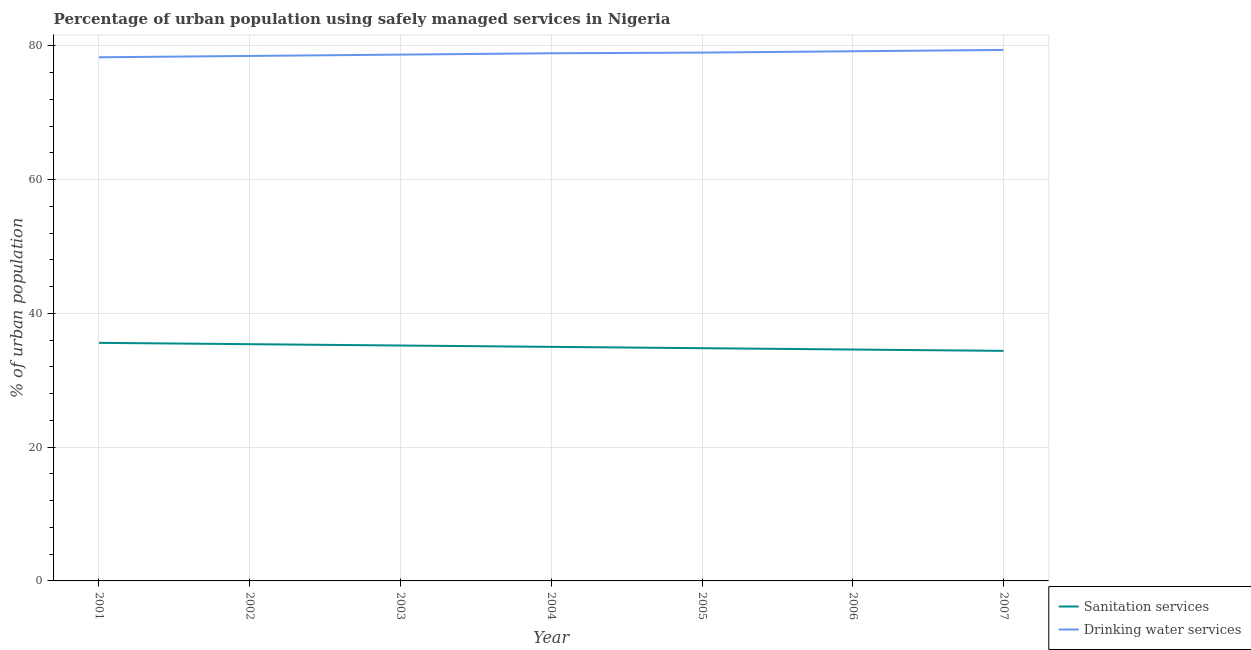Does the line corresponding to percentage of urban population who used drinking water services intersect with the line corresponding to percentage of urban population who used sanitation services?
Your response must be concise. No. What is the percentage of urban population who used sanitation services in 2007?
Ensure brevity in your answer.  34.4. Across all years, what is the maximum percentage of urban population who used drinking water services?
Provide a succinct answer. 79.4. Across all years, what is the minimum percentage of urban population who used drinking water services?
Ensure brevity in your answer.  78.3. In which year was the percentage of urban population who used drinking water services maximum?
Keep it short and to the point. 2007. In which year was the percentage of urban population who used drinking water services minimum?
Your response must be concise. 2001. What is the total percentage of urban population who used sanitation services in the graph?
Make the answer very short. 245. What is the difference between the percentage of urban population who used sanitation services in 2001 and that in 2003?
Give a very brief answer. 0.4. What is the difference between the percentage of urban population who used drinking water services in 2007 and the percentage of urban population who used sanitation services in 2006?
Provide a succinct answer. 44.8. What is the average percentage of urban population who used drinking water services per year?
Offer a terse response. 78.86. In the year 2001, what is the difference between the percentage of urban population who used drinking water services and percentage of urban population who used sanitation services?
Offer a very short reply. 42.7. In how many years, is the percentage of urban population who used drinking water services greater than 44 %?
Ensure brevity in your answer.  7. What is the ratio of the percentage of urban population who used sanitation services in 2002 to that in 2003?
Offer a very short reply. 1.01. What is the difference between the highest and the second highest percentage of urban population who used sanitation services?
Provide a short and direct response. 0.2. What is the difference between the highest and the lowest percentage of urban population who used sanitation services?
Ensure brevity in your answer.  1.2. Is the sum of the percentage of urban population who used drinking water services in 2001 and 2003 greater than the maximum percentage of urban population who used sanitation services across all years?
Your response must be concise. Yes. Does the percentage of urban population who used drinking water services monotonically increase over the years?
Give a very brief answer. Yes. Is the percentage of urban population who used drinking water services strictly less than the percentage of urban population who used sanitation services over the years?
Offer a terse response. No. How many years are there in the graph?
Offer a very short reply. 7. What is the difference between two consecutive major ticks on the Y-axis?
Make the answer very short. 20. Does the graph contain grids?
Offer a very short reply. Yes. Where does the legend appear in the graph?
Ensure brevity in your answer.  Bottom right. How are the legend labels stacked?
Ensure brevity in your answer.  Vertical. What is the title of the graph?
Offer a terse response. Percentage of urban population using safely managed services in Nigeria. Does "Private funds" appear as one of the legend labels in the graph?
Your answer should be very brief. No. What is the label or title of the Y-axis?
Your answer should be compact. % of urban population. What is the % of urban population of Sanitation services in 2001?
Your answer should be very brief. 35.6. What is the % of urban population of Drinking water services in 2001?
Offer a very short reply. 78.3. What is the % of urban population in Sanitation services in 2002?
Your answer should be compact. 35.4. What is the % of urban population in Drinking water services in 2002?
Make the answer very short. 78.5. What is the % of urban population of Sanitation services in 2003?
Your answer should be very brief. 35.2. What is the % of urban population of Drinking water services in 2003?
Provide a succinct answer. 78.7. What is the % of urban population of Sanitation services in 2004?
Your response must be concise. 35. What is the % of urban population of Drinking water services in 2004?
Make the answer very short. 78.9. What is the % of urban population of Sanitation services in 2005?
Give a very brief answer. 34.8. What is the % of urban population of Drinking water services in 2005?
Provide a short and direct response. 79. What is the % of urban population of Sanitation services in 2006?
Offer a terse response. 34.6. What is the % of urban population in Drinking water services in 2006?
Keep it short and to the point. 79.2. What is the % of urban population of Sanitation services in 2007?
Give a very brief answer. 34.4. What is the % of urban population in Drinking water services in 2007?
Offer a very short reply. 79.4. Across all years, what is the maximum % of urban population of Sanitation services?
Provide a succinct answer. 35.6. Across all years, what is the maximum % of urban population in Drinking water services?
Your response must be concise. 79.4. Across all years, what is the minimum % of urban population in Sanitation services?
Offer a very short reply. 34.4. Across all years, what is the minimum % of urban population of Drinking water services?
Ensure brevity in your answer.  78.3. What is the total % of urban population of Sanitation services in the graph?
Provide a short and direct response. 245. What is the total % of urban population of Drinking water services in the graph?
Provide a succinct answer. 552. What is the difference between the % of urban population of Sanitation services in 2001 and that in 2003?
Ensure brevity in your answer.  0.4. What is the difference between the % of urban population in Drinking water services in 2001 and that in 2003?
Provide a succinct answer. -0.4. What is the difference between the % of urban population of Sanitation services in 2001 and that in 2004?
Make the answer very short. 0.6. What is the difference between the % of urban population in Sanitation services in 2001 and that in 2005?
Ensure brevity in your answer.  0.8. What is the difference between the % of urban population in Drinking water services in 2001 and that in 2006?
Offer a very short reply. -0.9. What is the difference between the % of urban population of Sanitation services in 2001 and that in 2007?
Provide a short and direct response. 1.2. What is the difference between the % of urban population in Drinking water services in 2002 and that in 2003?
Give a very brief answer. -0.2. What is the difference between the % of urban population in Sanitation services in 2002 and that in 2004?
Your response must be concise. 0.4. What is the difference between the % of urban population in Drinking water services in 2002 and that in 2005?
Provide a short and direct response. -0.5. What is the difference between the % of urban population in Sanitation services in 2002 and that in 2006?
Your answer should be very brief. 0.8. What is the difference between the % of urban population in Sanitation services in 2003 and that in 2004?
Your answer should be compact. 0.2. What is the difference between the % of urban population in Drinking water services in 2003 and that in 2005?
Provide a succinct answer. -0.3. What is the difference between the % of urban population in Drinking water services in 2003 and that in 2006?
Offer a very short reply. -0.5. What is the difference between the % of urban population of Drinking water services in 2003 and that in 2007?
Your answer should be very brief. -0.7. What is the difference between the % of urban population of Sanitation services in 2004 and that in 2005?
Offer a very short reply. 0.2. What is the difference between the % of urban population of Drinking water services in 2004 and that in 2005?
Your response must be concise. -0.1. What is the difference between the % of urban population in Sanitation services in 2004 and that in 2006?
Offer a very short reply. 0.4. What is the difference between the % of urban population of Drinking water services in 2004 and that in 2006?
Your answer should be very brief. -0.3. What is the difference between the % of urban population in Sanitation services in 2004 and that in 2007?
Your answer should be compact. 0.6. What is the difference between the % of urban population in Drinking water services in 2004 and that in 2007?
Give a very brief answer. -0.5. What is the difference between the % of urban population in Sanitation services in 2006 and that in 2007?
Provide a succinct answer. 0.2. What is the difference between the % of urban population of Sanitation services in 2001 and the % of urban population of Drinking water services in 2002?
Your answer should be compact. -42.9. What is the difference between the % of urban population of Sanitation services in 2001 and the % of urban population of Drinking water services in 2003?
Your answer should be very brief. -43.1. What is the difference between the % of urban population of Sanitation services in 2001 and the % of urban population of Drinking water services in 2004?
Offer a very short reply. -43.3. What is the difference between the % of urban population in Sanitation services in 2001 and the % of urban population in Drinking water services in 2005?
Provide a short and direct response. -43.4. What is the difference between the % of urban population of Sanitation services in 2001 and the % of urban population of Drinking water services in 2006?
Offer a very short reply. -43.6. What is the difference between the % of urban population of Sanitation services in 2001 and the % of urban population of Drinking water services in 2007?
Make the answer very short. -43.8. What is the difference between the % of urban population in Sanitation services in 2002 and the % of urban population in Drinking water services in 2003?
Your answer should be very brief. -43.3. What is the difference between the % of urban population in Sanitation services in 2002 and the % of urban population in Drinking water services in 2004?
Provide a succinct answer. -43.5. What is the difference between the % of urban population of Sanitation services in 2002 and the % of urban population of Drinking water services in 2005?
Keep it short and to the point. -43.6. What is the difference between the % of urban population of Sanitation services in 2002 and the % of urban population of Drinking water services in 2006?
Make the answer very short. -43.8. What is the difference between the % of urban population in Sanitation services in 2002 and the % of urban population in Drinking water services in 2007?
Provide a succinct answer. -44. What is the difference between the % of urban population of Sanitation services in 2003 and the % of urban population of Drinking water services in 2004?
Provide a succinct answer. -43.7. What is the difference between the % of urban population in Sanitation services in 2003 and the % of urban population in Drinking water services in 2005?
Your answer should be very brief. -43.8. What is the difference between the % of urban population in Sanitation services in 2003 and the % of urban population in Drinking water services in 2006?
Offer a very short reply. -44. What is the difference between the % of urban population of Sanitation services in 2003 and the % of urban population of Drinking water services in 2007?
Give a very brief answer. -44.2. What is the difference between the % of urban population of Sanitation services in 2004 and the % of urban population of Drinking water services in 2005?
Offer a terse response. -44. What is the difference between the % of urban population in Sanitation services in 2004 and the % of urban population in Drinking water services in 2006?
Offer a terse response. -44.2. What is the difference between the % of urban population of Sanitation services in 2004 and the % of urban population of Drinking water services in 2007?
Provide a succinct answer. -44.4. What is the difference between the % of urban population of Sanitation services in 2005 and the % of urban population of Drinking water services in 2006?
Your response must be concise. -44.4. What is the difference between the % of urban population in Sanitation services in 2005 and the % of urban population in Drinking water services in 2007?
Offer a terse response. -44.6. What is the difference between the % of urban population in Sanitation services in 2006 and the % of urban population in Drinking water services in 2007?
Ensure brevity in your answer.  -44.8. What is the average % of urban population of Sanitation services per year?
Make the answer very short. 35. What is the average % of urban population in Drinking water services per year?
Provide a succinct answer. 78.86. In the year 2001, what is the difference between the % of urban population in Sanitation services and % of urban population in Drinking water services?
Make the answer very short. -42.7. In the year 2002, what is the difference between the % of urban population in Sanitation services and % of urban population in Drinking water services?
Offer a terse response. -43.1. In the year 2003, what is the difference between the % of urban population in Sanitation services and % of urban population in Drinking water services?
Give a very brief answer. -43.5. In the year 2004, what is the difference between the % of urban population of Sanitation services and % of urban population of Drinking water services?
Ensure brevity in your answer.  -43.9. In the year 2005, what is the difference between the % of urban population of Sanitation services and % of urban population of Drinking water services?
Your response must be concise. -44.2. In the year 2006, what is the difference between the % of urban population in Sanitation services and % of urban population in Drinking water services?
Offer a terse response. -44.6. In the year 2007, what is the difference between the % of urban population of Sanitation services and % of urban population of Drinking water services?
Your response must be concise. -45. What is the ratio of the % of urban population in Sanitation services in 2001 to that in 2002?
Offer a very short reply. 1.01. What is the ratio of the % of urban population in Drinking water services in 2001 to that in 2002?
Offer a very short reply. 1. What is the ratio of the % of urban population of Sanitation services in 2001 to that in 2003?
Keep it short and to the point. 1.01. What is the ratio of the % of urban population of Drinking water services in 2001 to that in 2003?
Provide a short and direct response. 0.99. What is the ratio of the % of urban population in Sanitation services in 2001 to that in 2004?
Offer a very short reply. 1.02. What is the ratio of the % of urban population of Drinking water services in 2001 to that in 2004?
Provide a short and direct response. 0.99. What is the ratio of the % of urban population in Sanitation services in 2001 to that in 2005?
Your answer should be very brief. 1.02. What is the ratio of the % of urban population of Sanitation services in 2001 to that in 2006?
Your answer should be very brief. 1.03. What is the ratio of the % of urban population of Sanitation services in 2001 to that in 2007?
Keep it short and to the point. 1.03. What is the ratio of the % of urban population of Drinking water services in 2001 to that in 2007?
Make the answer very short. 0.99. What is the ratio of the % of urban population of Sanitation services in 2002 to that in 2003?
Your response must be concise. 1.01. What is the ratio of the % of urban population in Sanitation services in 2002 to that in 2004?
Offer a very short reply. 1.01. What is the ratio of the % of urban population in Drinking water services in 2002 to that in 2004?
Make the answer very short. 0.99. What is the ratio of the % of urban population in Sanitation services in 2002 to that in 2005?
Make the answer very short. 1.02. What is the ratio of the % of urban population in Drinking water services in 2002 to that in 2005?
Offer a terse response. 0.99. What is the ratio of the % of urban population of Sanitation services in 2002 to that in 2006?
Provide a succinct answer. 1.02. What is the ratio of the % of urban population in Sanitation services in 2002 to that in 2007?
Your response must be concise. 1.03. What is the ratio of the % of urban population of Drinking water services in 2002 to that in 2007?
Your response must be concise. 0.99. What is the ratio of the % of urban population in Sanitation services in 2003 to that in 2005?
Ensure brevity in your answer.  1.01. What is the ratio of the % of urban population in Drinking water services in 2003 to that in 2005?
Keep it short and to the point. 1. What is the ratio of the % of urban population of Sanitation services in 2003 to that in 2006?
Provide a short and direct response. 1.02. What is the ratio of the % of urban population in Drinking water services in 2003 to that in 2006?
Your response must be concise. 0.99. What is the ratio of the % of urban population in Sanitation services in 2003 to that in 2007?
Ensure brevity in your answer.  1.02. What is the ratio of the % of urban population in Drinking water services in 2003 to that in 2007?
Your answer should be compact. 0.99. What is the ratio of the % of urban population of Sanitation services in 2004 to that in 2005?
Keep it short and to the point. 1.01. What is the ratio of the % of urban population of Drinking water services in 2004 to that in 2005?
Your answer should be compact. 1. What is the ratio of the % of urban population in Sanitation services in 2004 to that in 2006?
Provide a succinct answer. 1.01. What is the ratio of the % of urban population of Drinking water services in 2004 to that in 2006?
Your answer should be compact. 1. What is the ratio of the % of urban population in Sanitation services in 2004 to that in 2007?
Offer a very short reply. 1.02. What is the ratio of the % of urban population of Drinking water services in 2004 to that in 2007?
Make the answer very short. 0.99. What is the ratio of the % of urban population in Sanitation services in 2005 to that in 2006?
Offer a terse response. 1.01. What is the ratio of the % of urban population in Sanitation services in 2005 to that in 2007?
Offer a terse response. 1.01. What is the ratio of the % of urban population in Sanitation services in 2006 to that in 2007?
Offer a terse response. 1.01. What is the difference between the highest and the lowest % of urban population of Sanitation services?
Your answer should be compact. 1.2. 